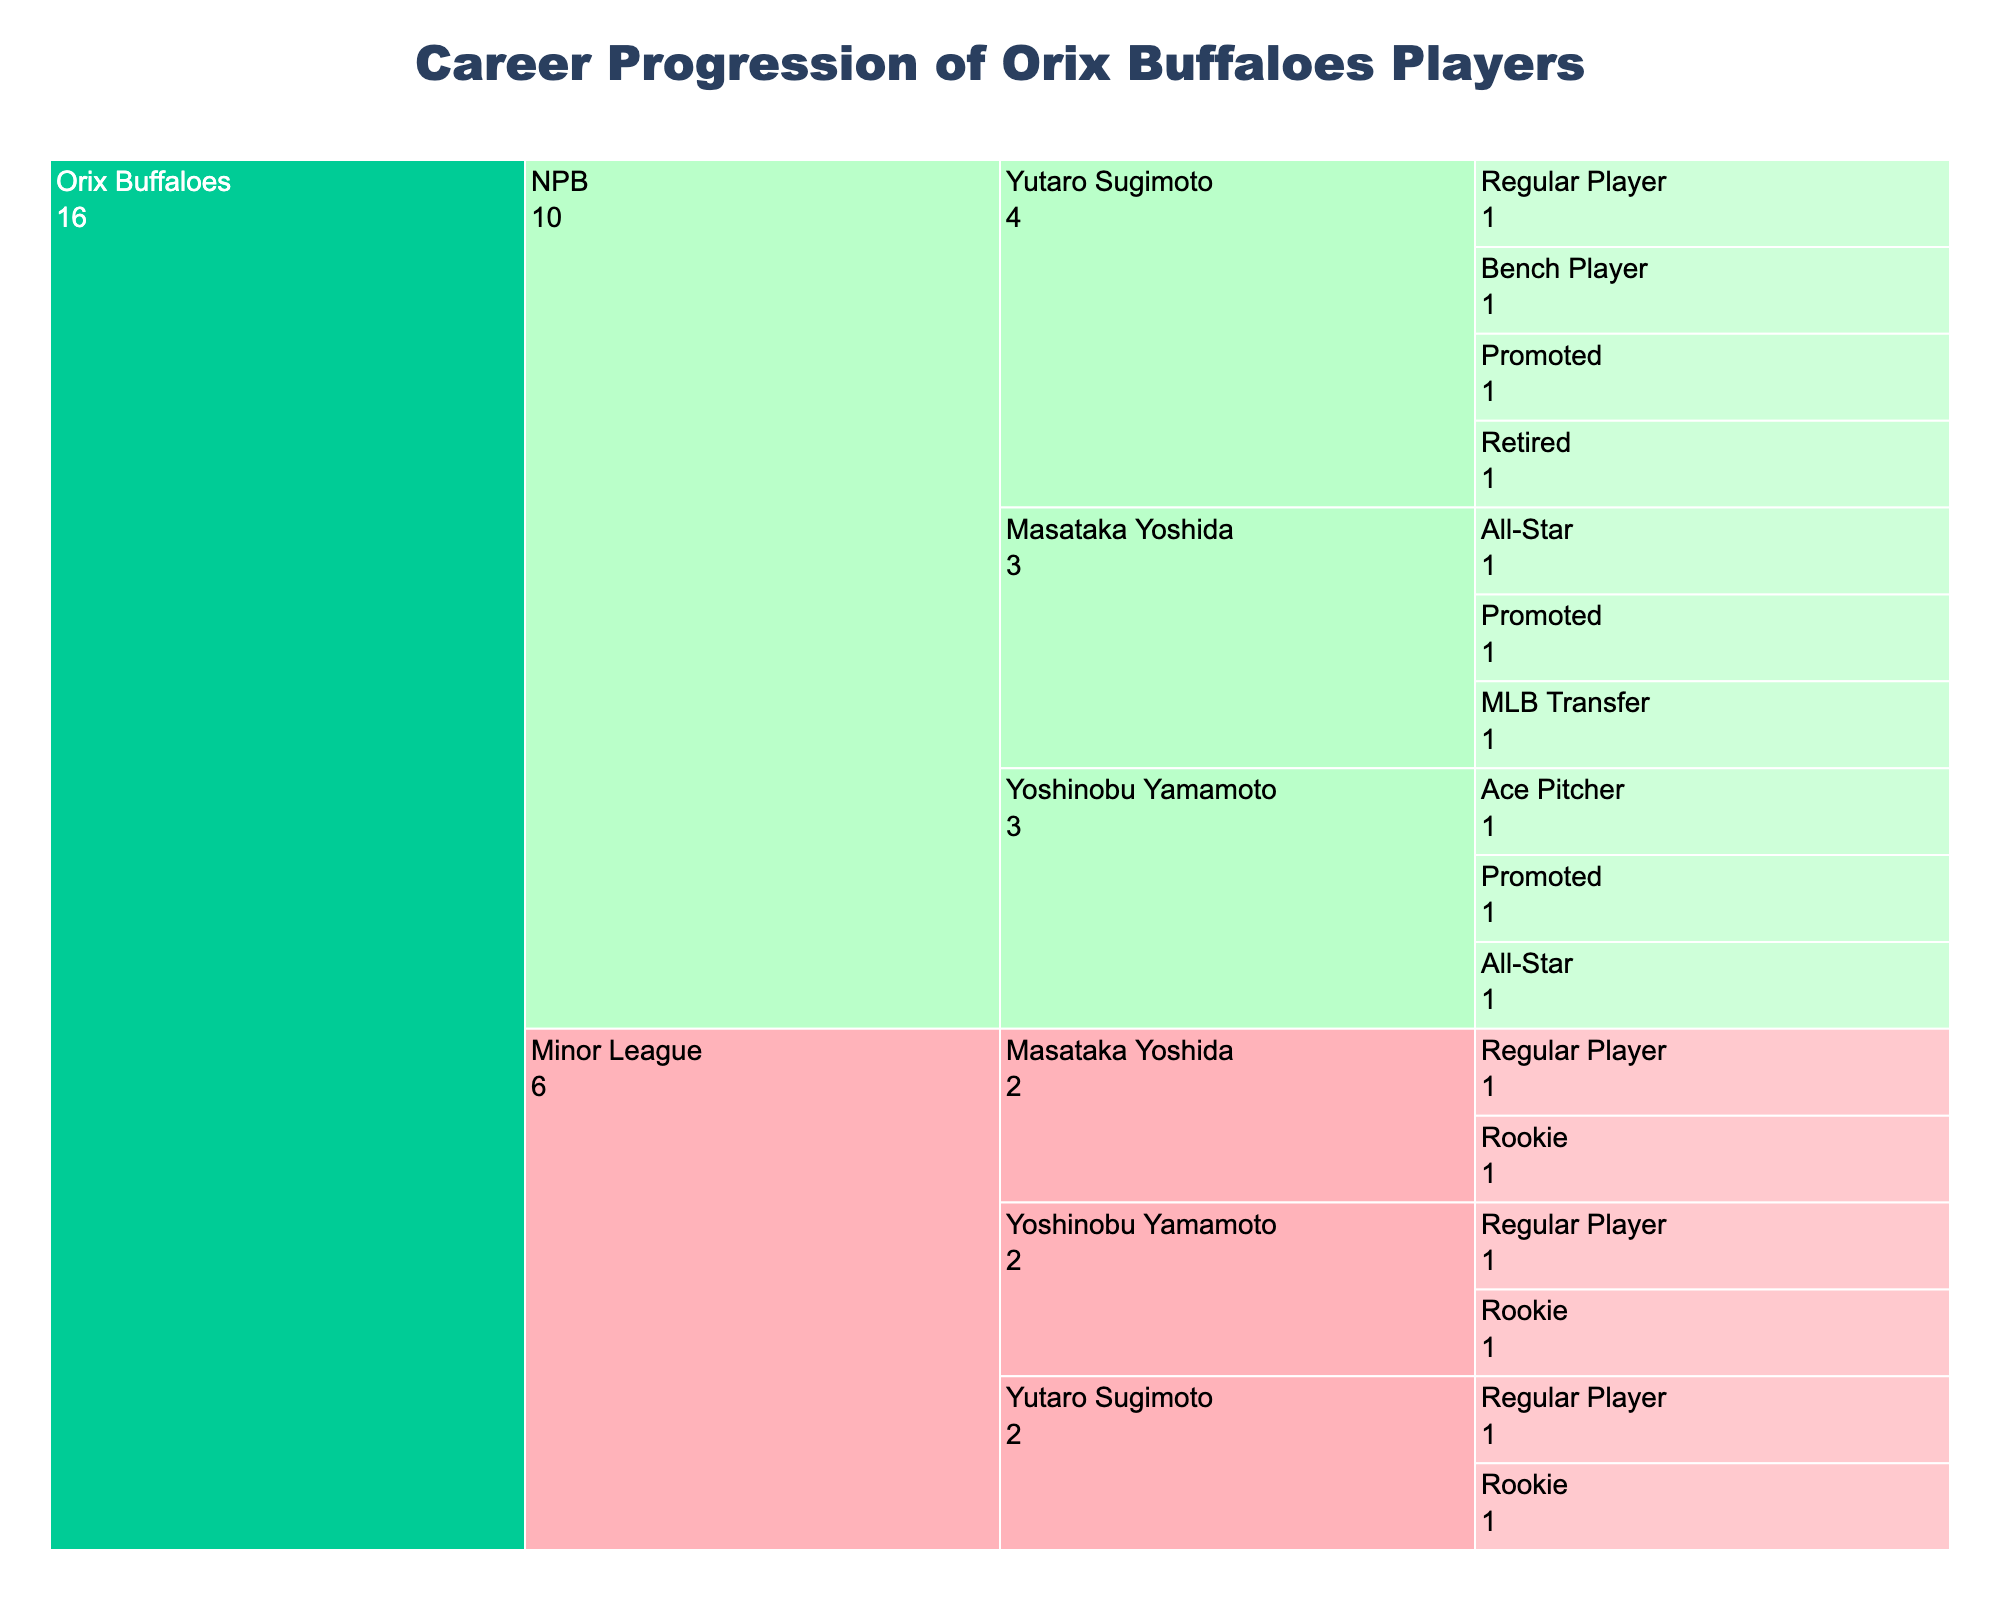How many players started in the Minor League as Rookies for the Orix Buffaloes? From the icicle chart, count the branches under "Orix Buffaloes" > "Minor League" > "Rookie". There are three players listed: Masataka Yoshida, Yoshinobu Yamamoto, and Yutaro Sugimoto.
Answer: 3 Which player reached the status of Ace Pitcher in the NPB? In the icicle chart, navigate to "Orix Buffaloes" > "NPB" and look for the specific status of "Ace Pitcher". The only player who reached this status is Yoshinobu Yamamoto.
Answer: Yoshinobu Yamamoto Which levels has Masataka Yoshida played in during his career? Check the levels listed under Masataka Yoshida in the icicle chart: "Orix Buffaloes" > "Minor League" and "Orix Buffaloes" > "NPB".
Answer: Minor League and NPB List the statuses Yutaro Sugimoto achieved in the NPB before retiring. Under "Orix Buffaloes" > "NPB" > "Yutaro Sugimoto", read through the listed statuses: "Promoted", "Bench Player", "Regular Player", and "Retired".
Answer: Promoted, Bench Player, Regular Player, Retired How many players transferred to the MLB from the Orix Buffaloes? Check the icicle chart for players whose status path includes "MLB Transfer". Only one player, Masataka Yoshida, transferred to the MLB.
Answer: 1 Who among the players reached the All-Star status in the NPB? Navigate through the paths under "Orix Buffaloes" > "NPB" > "All-Star". Both Masataka Yoshida and Yoshinobu Yamamoto achieved All-Star status.
Answer: Masataka Yoshida, Yoshinobu Yamamoto Compare the number of players in the Minor League and NPB. Which has more? Count the unique players listed in each level. In the Minor League, there are Masataka Yoshida, Yoshinobu Yamamoto, and Yutaro Sugimoto (3 players). In the NPB, all three are still present: Masataka Yoshida, Yoshinobu Yamamoto, and Yutaro Sugimoto (3 players).
Answer: Same Which player has the most career progression paths documented in the chart? Count the number of statuses under each player in the icicle chart. Masataka Yoshida and Yutaro Sugimoto both have 5 documented statuses, while Yoshinobu Yamamoto has 5 too. Hence, they all have the same number of career progression paths documented.
Answer: Masataka Yoshida, Yoshinobu Yamamoto, Yutaro Sugimoto What is the title of the icicle chart? Read the title shown at the top of the icicle chart. It is "Career Progression of Orix Buffaloes Players".
Answer: Career Progression of Orix Buffaloes Players 